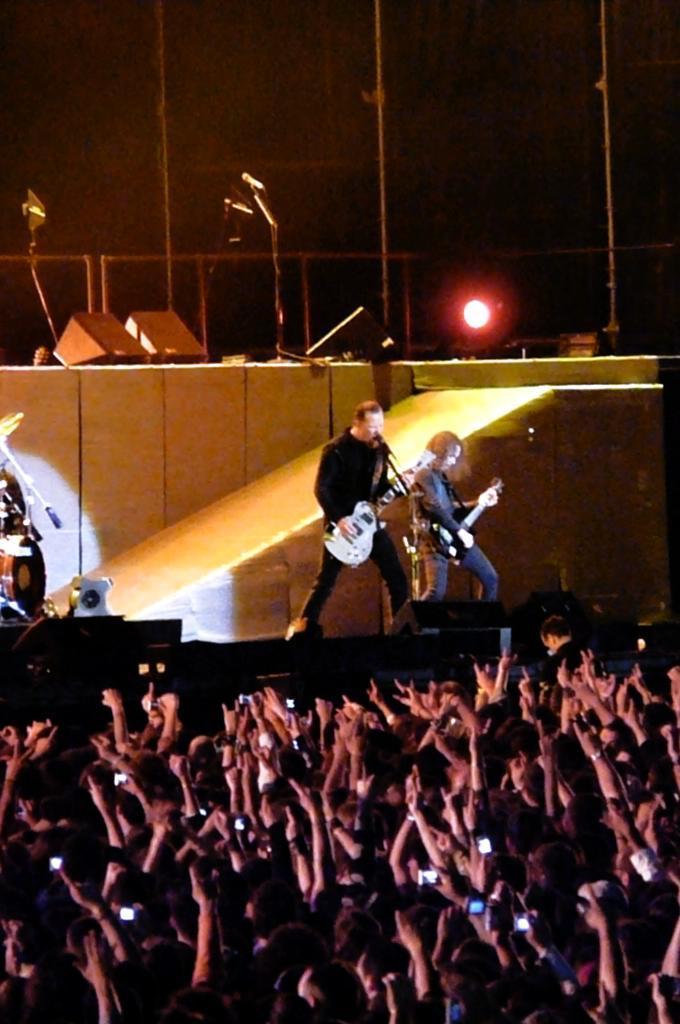Describe this image in one or two sentences. In this image, there are a few people. Among them, some people on the stage are playing musical instruments. We can see some objects on the stage. We can see some microphones, ropes and the wall. We can see the fence and a light. 